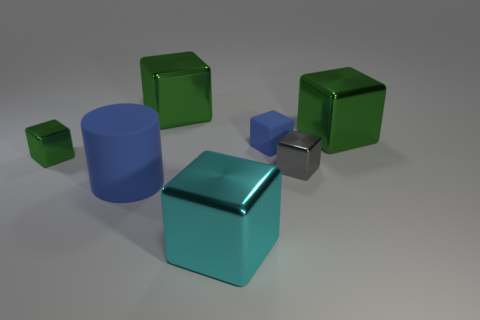There is a blue cylinder that is the same size as the cyan thing; what is it made of?
Provide a succinct answer. Rubber. Are there any big cyan blocks that have the same material as the large cyan thing?
Your response must be concise. No. Do the gray thing and the blue object that is in front of the small gray object have the same shape?
Ensure brevity in your answer.  No. What number of objects are on the right side of the cylinder and in front of the small gray block?
Your answer should be compact. 1. Do the cyan cube and the green thing that is to the right of the tiny blue rubber block have the same material?
Make the answer very short. Yes. Are there an equal number of large cubes to the right of the cyan metallic object and green shiny objects?
Provide a short and direct response. No. What color is the tiny shiny cube on the right side of the large cyan cube?
Your answer should be compact. Gray. Are there any other things that have the same size as the blue cube?
Provide a succinct answer. Yes. Do the green shiny cube that is to the right of the blue cube and the blue rubber cylinder have the same size?
Give a very brief answer. Yes. There is a blue thing left of the tiny blue rubber block; what is it made of?
Your answer should be compact. Rubber. 